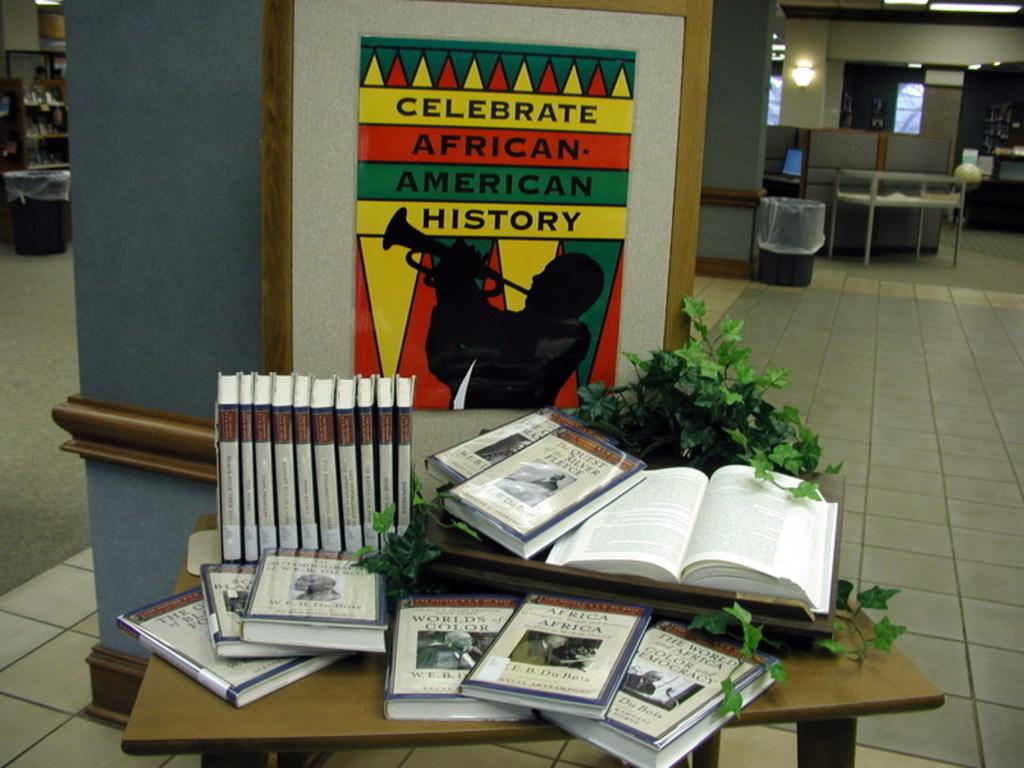<image>
Relay a brief, clear account of the picture shown. A poster about celebrating African-American history is hanging on the wall in a library. 